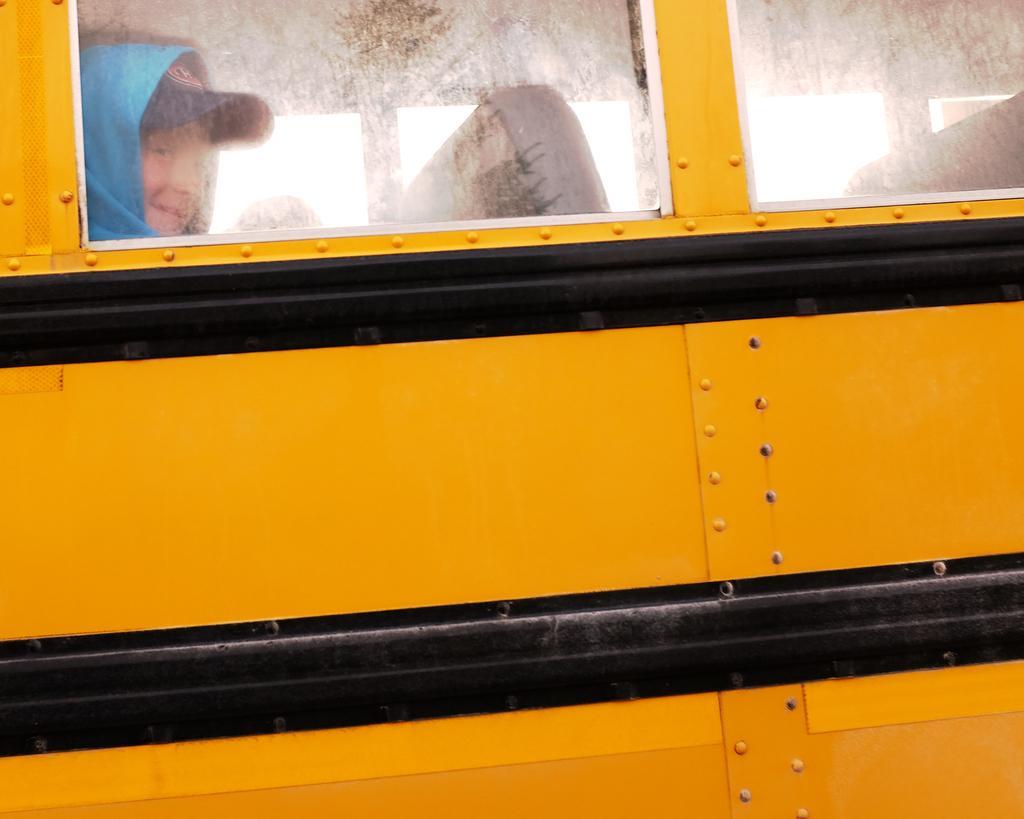Describe this image in one or two sentences. In this image we can see a vehicle which is truncated. Through the windows we can see a person and seats. 